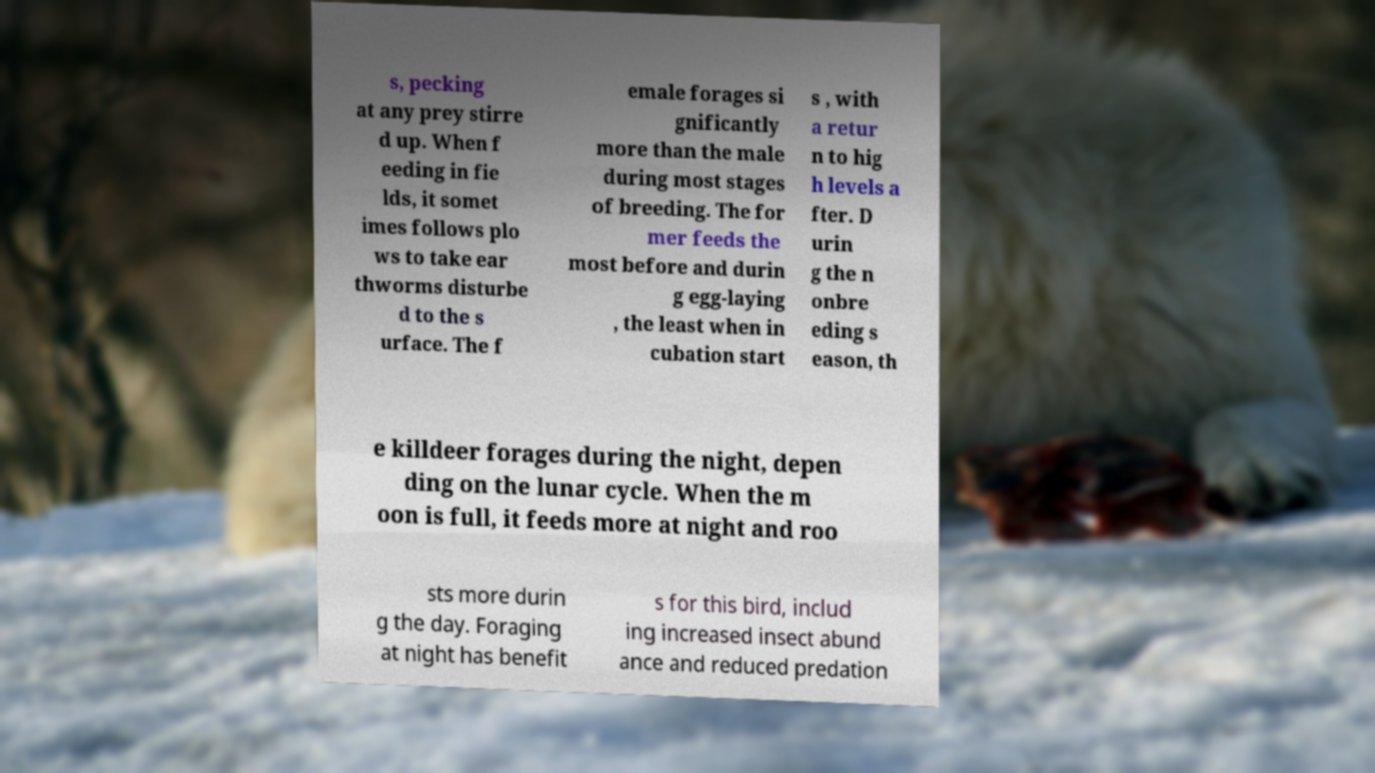Please read and relay the text visible in this image. What does it say? s, pecking at any prey stirre d up. When f eeding in fie lds, it somet imes follows plo ws to take ear thworms disturbe d to the s urface. The f emale forages si gnificantly more than the male during most stages of breeding. The for mer feeds the most before and durin g egg-laying , the least when in cubation start s , with a retur n to hig h levels a fter. D urin g the n onbre eding s eason, th e killdeer forages during the night, depen ding on the lunar cycle. When the m oon is full, it feeds more at night and roo sts more durin g the day. Foraging at night has benefit s for this bird, includ ing increased insect abund ance and reduced predation 